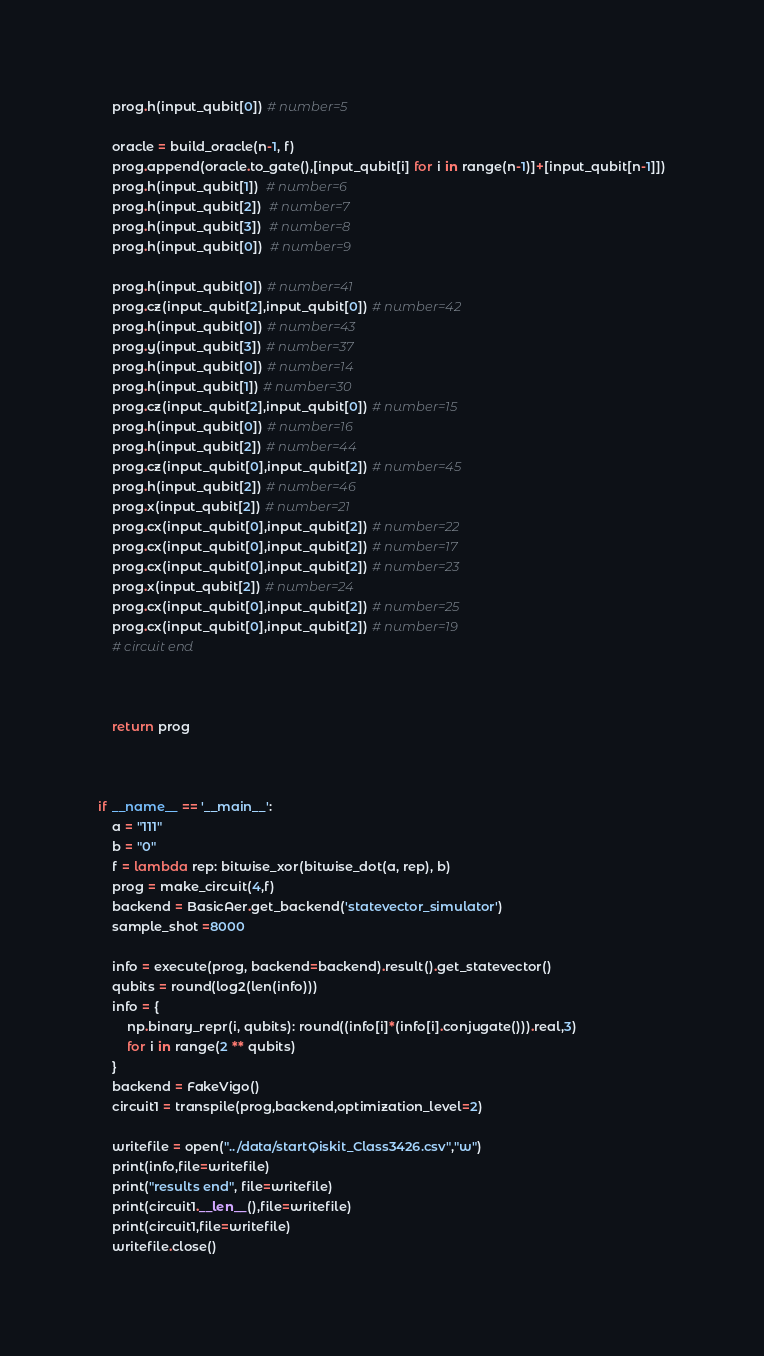<code> <loc_0><loc_0><loc_500><loc_500><_Python_>    prog.h(input_qubit[0]) # number=5

    oracle = build_oracle(n-1, f)
    prog.append(oracle.to_gate(),[input_qubit[i] for i in range(n-1)]+[input_qubit[n-1]])
    prog.h(input_qubit[1])  # number=6
    prog.h(input_qubit[2])  # number=7
    prog.h(input_qubit[3])  # number=8
    prog.h(input_qubit[0])  # number=9

    prog.h(input_qubit[0]) # number=41
    prog.cz(input_qubit[2],input_qubit[0]) # number=42
    prog.h(input_qubit[0]) # number=43
    prog.y(input_qubit[3]) # number=37
    prog.h(input_qubit[0]) # number=14
    prog.h(input_qubit[1]) # number=30
    prog.cz(input_qubit[2],input_qubit[0]) # number=15
    prog.h(input_qubit[0]) # number=16
    prog.h(input_qubit[2]) # number=44
    prog.cz(input_qubit[0],input_qubit[2]) # number=45
    prog.h(input_qubit[2]) # number=46
    prog.x(input_qubit[2]) # number=21
    prog.cx(input_qubit[0],input_qubit[2]) # number=22
    prog.cx(input_qubit[0],input_qubit[2]) # number=17
    prog.cx(input_qubit[0],input_qubit[2]) # number=23
    prog.x(input_qubit[2]) # number=24
    prog.cx(input_qubit[0],input_qubit[2]) # number=25
    prog.cx(input_qubit[0],input_qubit[2]) # number=19
    # circuit end



    return prog



if __name__ == '__main__':
    a = "111"
    b = "0"
    f = lambda rep: bitwise_xor(bitwise_dot(a, rep), b)
    prog = make_circuit(4,f)
    backend = BasicAer.get_backend('statevector_simulator')
    sample_shot =8000

    info = execute(prog, backend=backend).result().get_statevector()
    qubits = round(log2(len(info)))
    info = {
        np.binary_repr(i, qubits): round((info[i]*(info[i].conjugate())).real,3)
        for i in range(2 ** qubits)
    }
    backend = FakeVigo()
    circuit1 = transpile(prog,backend,optimization_level=2)

    writefile = open("../data/startQiskit_Class3426.csv","w")
    print(info,file=writefile)
    print("results end", file=writefile)
    print(circuit1.__len__(),file=writefile)
    print(circuit1,file=writefile)
    writefile.close()
</code> 